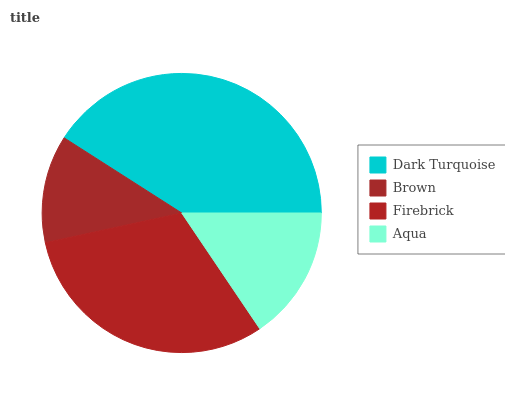Is Brown the minimum?
Answer yes or no. Yes. Is Dark Turquoise the maximum?
Answer yes or no. Yes. Is Firebrick the minimum?
Answer yes or no. No. Is Firebrick the maximum?
Answer yes or no. No. Is Firebrick greater than Brown?
Answer yes or no. Yes. Is Brown less than Firebrick?
Answer yes or no. Yes. Is Brown greater than Firebrick?
Answer yes or no. No. Is Firebrick less than Brown?
Answer yes or no. No. Is Firebrick the high median?
Answer yes or no. Yes. Is Aqua the low median?
Answer yes or no. Yes. Is Brown the high median?
Answer yes or no. No. Is Brown the low median?
Answer yes or no. No. 